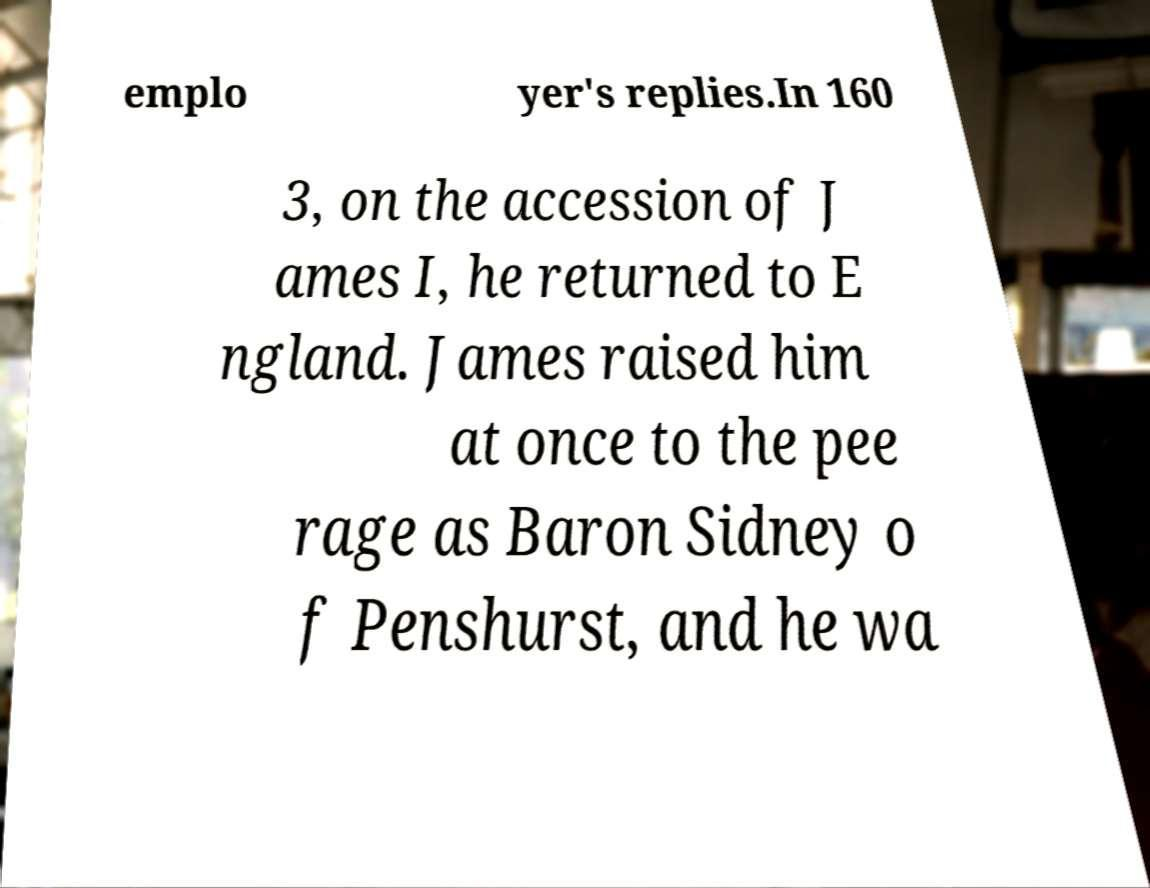Please read and relay the text visible in this image. What does it say? emplo yer's replies.In 160 3, on the accession of J ames I, he returned to E ngland. James raised him at once to the pee rage as Baron Sidney o f Penshurst, and he wa 